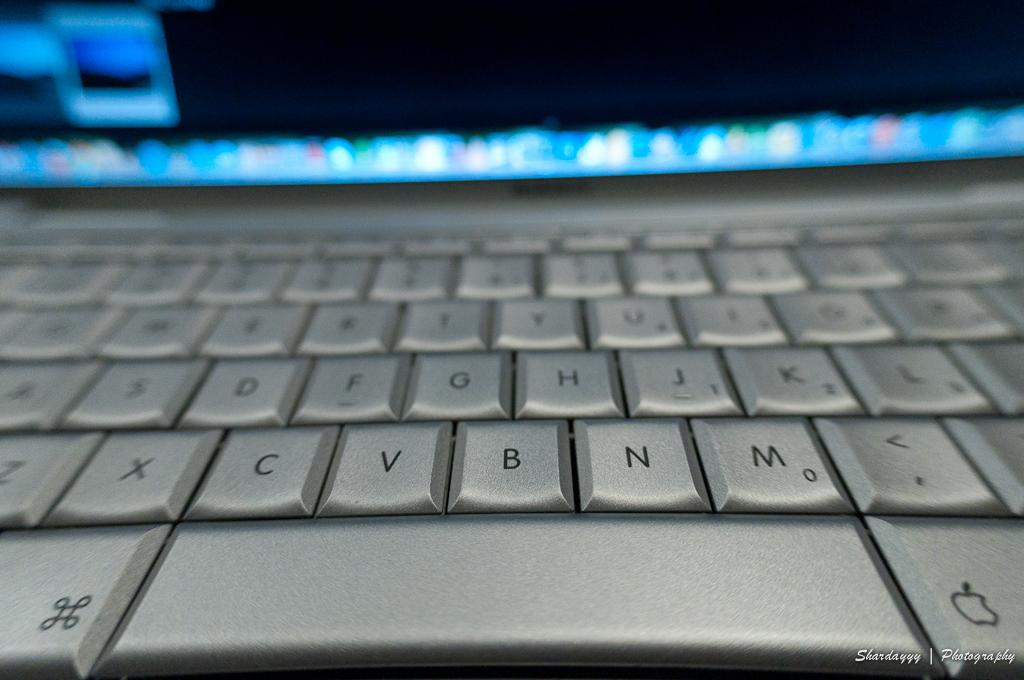<image>
Give a short and clear explanation of the subsequent image. a keyboard on a mac computer that has silver keys on it 